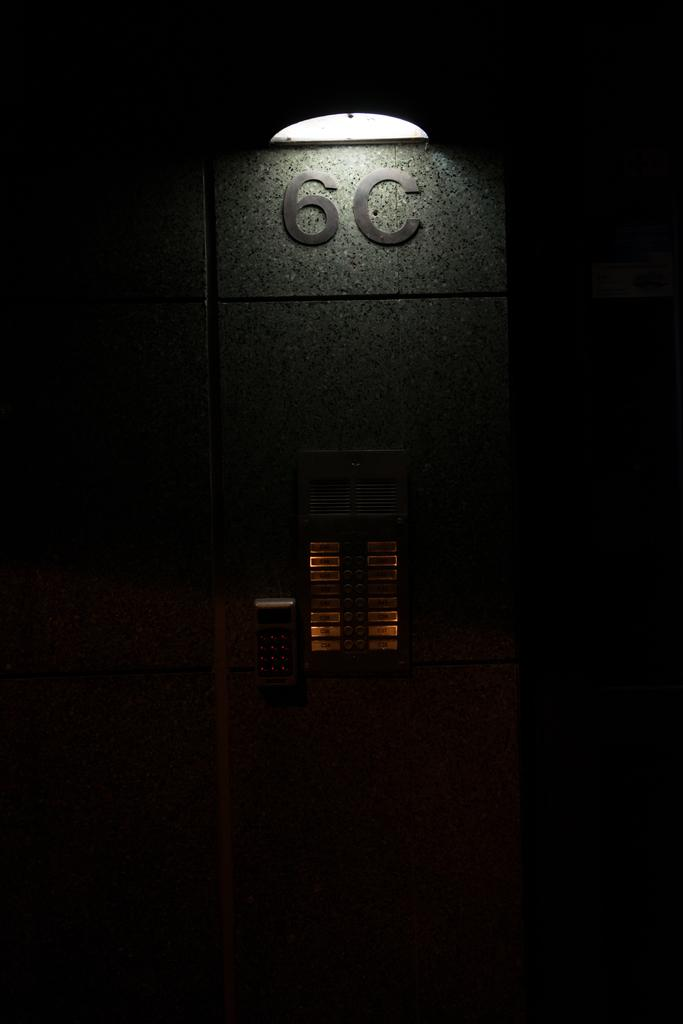How would you describe the overall lighting in the image? The image is dark. What object in the image might provide light? There is a lamp in the image. Is there any text or numbers visible in the image? Yes, the number "6C" is written on the wall in the image. What type of device is present in the image? There is an electronic device in the image. How might the electronic device be controlled or operated? The electronic device has buttons. Can you see anyone kicking a banana in the image? There is no banana or person kicking in the image. How does the room's atmosphere affect the breathing of the people in the image? There are no people present in the image, so their breathing cannot be observed or affected by the room's atmosphere. 